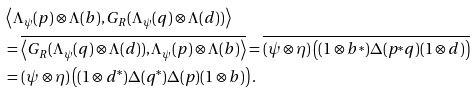<formula> <loc_0><loc_0><loc_500><loc_500>& \left \langle \Lambda _ { \psi } ( p ) \otimes \Lambda ( b ) , G _ { R } ( \Lambda _ { \psi } ( q ) \otimes \Lambda ( d ) ) \right \rangle \\ & = \overline { \left \langle G _ { R } ( \Lambda _ { \psi } ( q ) \otimes \Lambda ( d ) ) , \Lambda _ { \psi } ( p ) \otimes \Lambda ( b ) \right \rangle } = \overline { ( \psi \otimes \eta ) \left ( ( 1 \otimes b ^ { * } ) \Delta ( p ^ { * } q ) ( 1 \otimes d ) \right ) } \\ & = ( \psi \otimes \eta ) \left ( ( 1 \otimes d ^ { * } ) \Delta ( q ^ { * } ) \Delta ( p ) ( 1 \otimes b ) \right ) .</formula> 